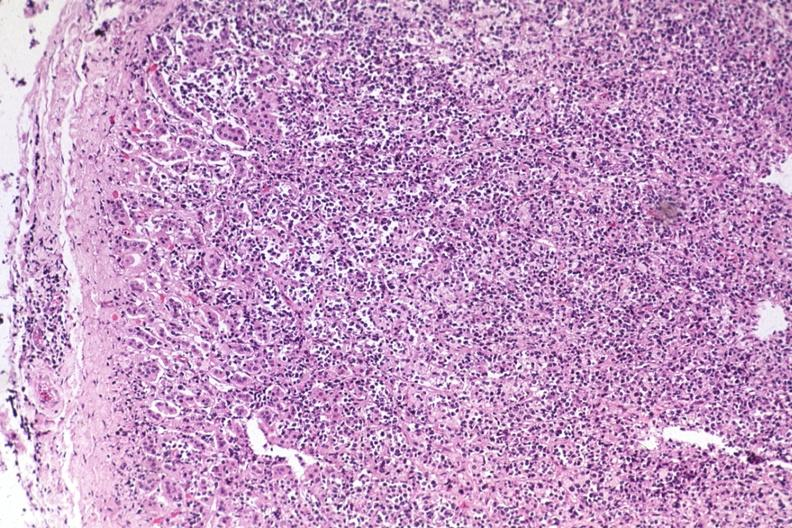what is present?
Answer the question using a single word or phrase. Malignant lymphoma 